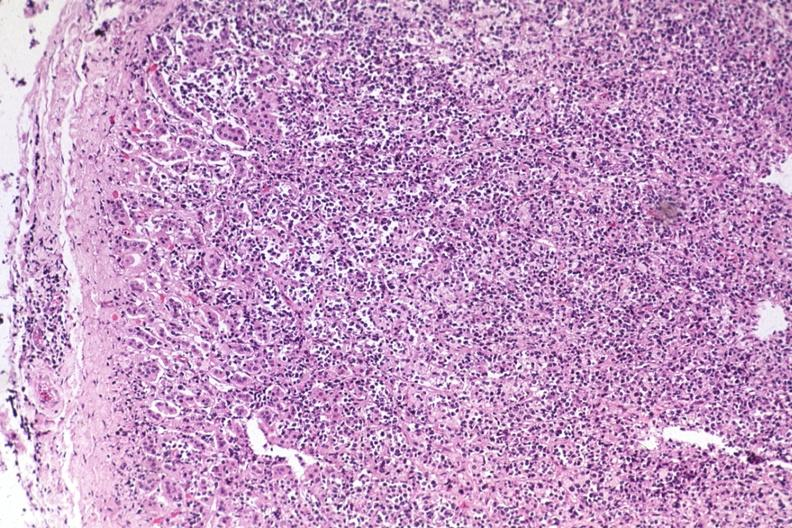what is present?
Answer the question using a single word or phrase. Malignant lymphoma 